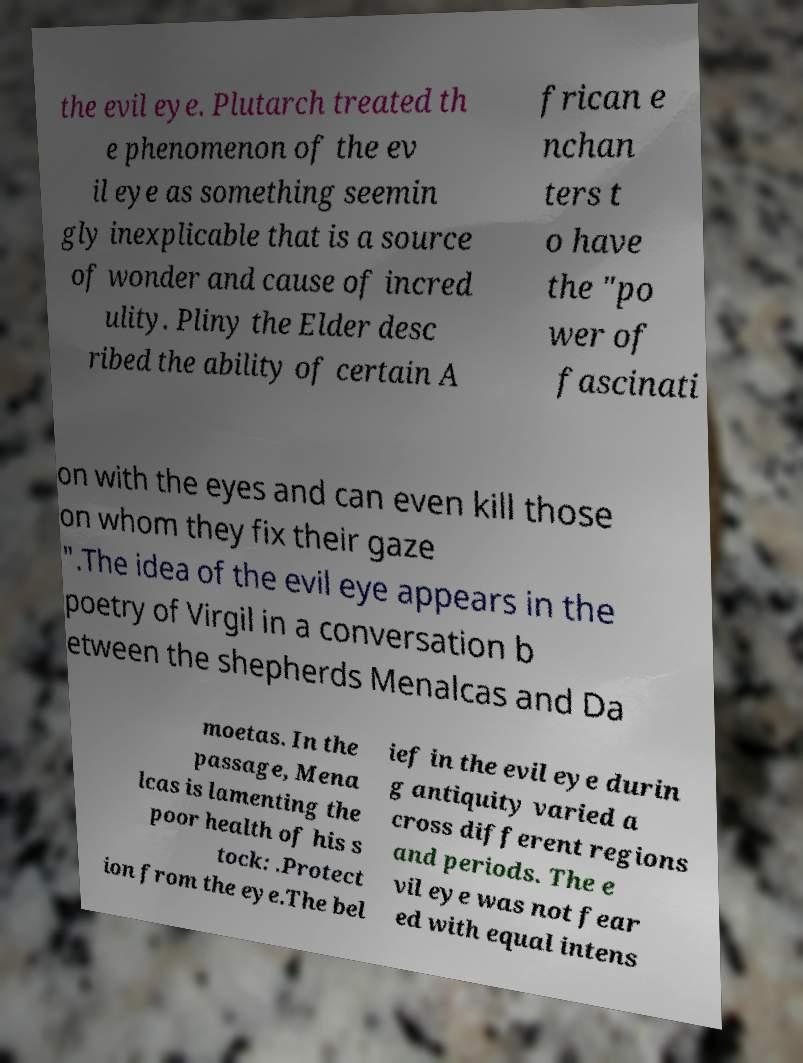For documentation purposes, I need the text within this image transcribed. Could you provide that? the evil eye. Plutarch treated th e phenomenon of the ev il eye as something seemin gly inexplicable that is a source of wonder and cause of incred ulity. Pliny the Elder desc ribed the ability of certain A frican e nchan ters t o have the "po wer of fascinati on with the eyes and can even kill those on whom they fix their gaze ".The idea of the evil eye appears in the poetry of Virgil in a conversation b etween the shepherds Menalcas and Da moetas. In the passage, Mena lcas is lamenting the poor health of his s tock: .Protect ion from the eye.The bel ief in the evil eye durin g antiquity varied a cross different regions and periods. The e vil eye was not fear ed with equal intens 